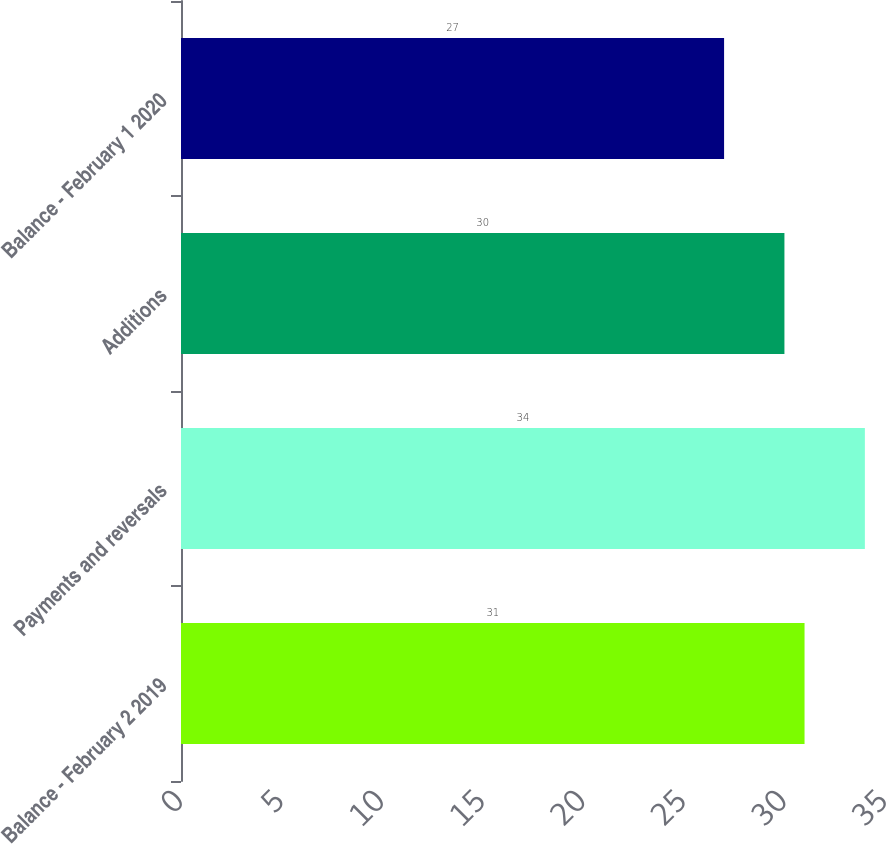Convert chart. <chart><loc_0><loc_0><loc_500><loc_500><bar_chart><fcel>Balance - February 2 2019<fcel>Payments and reversals<fcel>Additions<fcel>Balance - February 1 2020<nl><fcel>31<fcel>34<fcel>30<fcel>27<nl></chart> 